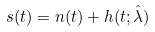Convert formula to latex. <formula><loc_0><loc_0><loc_500><loc_500>s ( t ) = n ( t ) + h ( t ; \hat { \lambda } )</formula> 